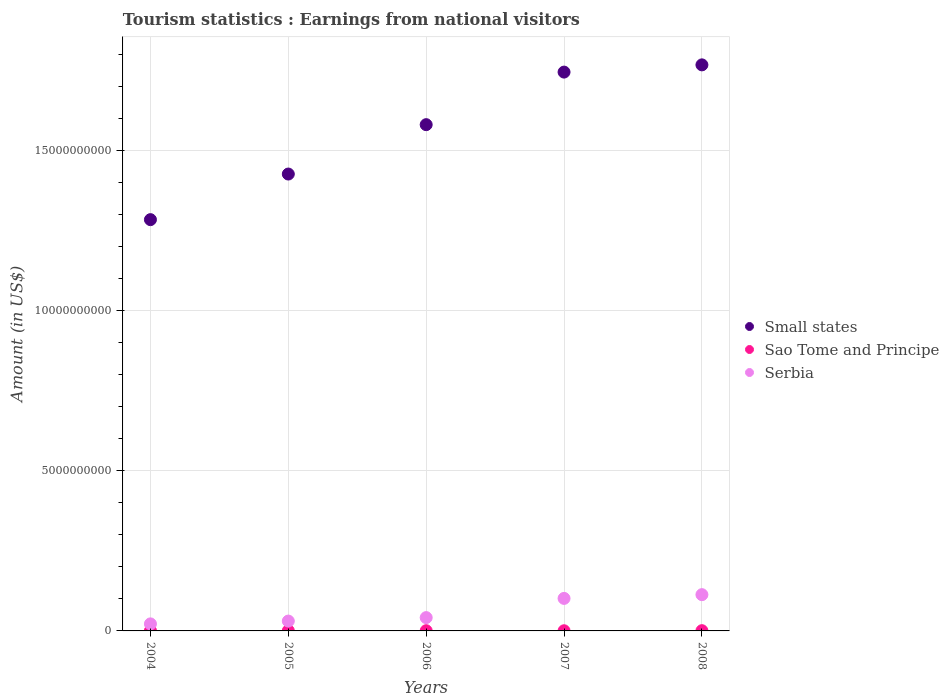What is the earnings from national visitors in Serbia in 2005?
Offer a very short reply. 3.08e+08. Across all years, what is the maximum earnings from national visitors in Serbia?
Your answer should be compact. 1.13e+09. Across all years, what is the minimum earnings from national visitors in Small states?
Provide a short and direct response. 1.29e+1. In which year was the earnings from national visitors in Sao Tome and Principe minimum?
Provide a short and direct response. 2007. What is the total earnings from national visitors in Sao Tome and Principe in the graph?
Your answer should be very brief. 3.44e+07. What is the difference between the earnings from national visitors in Small states in 2005 and that in 2006?
Give a very brief answer. -1.54e+09. What is the difference between the earnings from national visitors in Serbia in 2006 and the earnings from national visitors in Sao Tome and Principe in 2008?
Keep it short and to the point. 4.08e+08. What is the average earnings from national visitors in Small states per year?
Give a very brief answer. 1.56e+1. In the year 2006, what is the difference between the earnings from national visitors in Sao Tome and Principe and earnings from national visitors in Small states?
Offer a terse response. -1.58e+1. In how many years, is the earnings from national visitors in Serbia greater than 1000000000 US$?
Your answer should be compact. 2. What is the ratio of the earnings from national visitors in Small states in 2007 to that in 2008?
Give a very brief answer. 0.99. What is the difference between the highest and the second highest earnings from national visitors in Serbia?
Your answer should be very brief. 1.17e+08. What is the difference between the highest and the lowest earnings from national visitors in Small states?
Make the answer very short. 4.84e+09. Is the earnings from national visitors in Small states strictly greater than the earnings from national visitors in Sao Tome and Principe over the years?
Offer a terse response. Yes. Is the earnings from national visitors in Small states strictly less than the earnings from national visitors in Sao Tome and Principe over the years?
Give a very brief answer. No. What is the difference between two consecutive major ticks on the Y-axis?
Give a very brief answer. 5.00e+09. Are the values on the major ticks of Y-axis written in scientific E-notation?
Make the answer very short. No. Where does the legend appear in the graph?
Keep it short and to the point. Center right. How are the legend labels stacked?
Ensure brevity in your answer.  Vertical. What is the title of the graph?
Your response must be concise. Tourism statistics : Earnings from national visitors. What is the label or title of the X-axis?
Give a very brief answer. Years. What is the label or title of the Y-axis?
Ensure brevity in your answer.  Amount (in US$). What is the Amount (in US$) of Small states in 2004?
Your response must be concise. 1.29e+1. What is the Amount (in US$) of Sao Tome and Principe in 2004?
Your answer should be very brief. 7.70e+06. What is the Amount (in US$) in Serbia in 2004?
Provide a short and direct response. 2.20e+08. What is the Amount (in US$) of Small states in 2005?
Make the answer very short. 1.43e+1. What is the Amount (in US$) in Sao Tome and Principe in 2005?
Provide a succinct answer. 7.30e+06. What is the Amount (in US$) in Serbia in 2005?
Ensure brevity in your answer.  3.08e+08. What is the Amount (in US$) in Small states in 2006?
Your answer should be compact. 1.58e+1. What is the Amount (in US$) of Sao Tome and Principe in 2006?
Provide a short and direct response. 6.70e+06. What is the Amount (in US$) of Serbia in 2006?
Offer a terse response. 4.16e+08. What is the Amount (in US$) in Small states in 2007?
Your response must be concise. 1.75e+1. What is the Amount (in US$) in Serbia in 2007?
Keep it short and to the point. 1.02e+09. What is the Amount (in US$) of Small states in 2008?
Make the answer very short. 1.77e+1. What is the Amount (in US$) of Sao Tome and Principe in 2008?
Your answer should be compact. 7.70e+06. What is the Amount (in US$) of Serbia in 2008?
Your answer should be very brief. 1.13e+09. Across all years, what is the maximum Amount (in US$) of Small states?
Ensure brevity in your answer.  1.77e+1. Across all years, what is the maximum Amount (in US$) in Sao Tome and Principe?
Provide a succinct answer. 7.70e+06. Across all years, what is the maximum Amount (in US$) of Serbia?
Make the answer very short. 1.13e+09. Across all years, what is the minimum Amount (in US$) in Small states?
Your answer should be compact. 1.29e+1. Across all years, what is the minimum Amount (in US$) in Serbia?
Provide a short and direct response. 2.20e+08. What is the total Amount (in US$) in Small states in the graph?
Ensure brevity in your answer.  7.81e+1. What is the total Amount (in US$) of Sao Tome and Principe in the graph?
Offer a terse response. 3.44e+07. What is the total Amount (in US$) of Serbia in the graph?
Your answer should be very brief. 3.09e+09. What is the difference between the Amount (in US$) of Small states in 2004 and that in 2005?
Your response must be concise. -1.43e+09. What is the difference between the Amount (in US$) of Sao Tome and Principe in 2004 and that in 2005?
Ensure brevity in your answer.  4.00e+05. What is the difference between the Amount (in US$) in Serbia in 2004 and that in 2005?
Offer a terse response. -8.80e+07. What is the difference between the Amount (in US$) in Small states in 2004 and that in 2006?
Make the answer very short. -2.97e+09. What is the difference between the Amount (in US$) in Serbia in 2004 and that in 2006?
Give a very brief answer. -1.96e+08. What is the difference between the Amount (in US$) in Small states in 2004 and that in 2007?
Provide a short and direct response. -4.61e+09. What is the difference between the Amount (in US$) in Sao Tome and Principe in 2004 and that in 2007?
Your answer should be very brief. 2.70e+06. What is the difference between the Amount (in US$) of Serbia in 2004 and that in 2007?
Make the answer very short. -7.96e+08. What is the difference between the Amount (in US$) in Small states in 2004 and that in 2008?
Offer a very short reply. -4.84e+09. What is the difference between the Amount (in US$) of Sao Tome and Principe in 2004 and that in 2008?
Give a very brief answer. 0. What is the difference between the Amount (in US$) in Serbia in 2004 and that in 2008?
Ensure brevity in your answer.  -9.13e+08. What is the difference between the Amount (in US$) of Small states in 2005 and that in 2006?
Your answer should be compact. -1.54e+09. What is the difference between the Amount (in US$) in Serbia in 2005 and that in 2006?
Ensure brevity in your answer.  -1.08e+08. What is the difference between the Amount (in US$) in Small states in 2005 and that in 2007?
Give a very brief answer. -3.19e+09. What is the difference between the Amount (in US$) in Sao Tome and Principe in 2005 and that in 2007?
Offer a terse response. 2.30e+06. What is the difference between the Amount (in US$) in Serbia in 2005 and that in 2007?
Give a very brief answer. -7.08e+08. What is the difference between the Amount (in US$) of Small states in 2005 and that in 2008?
Your answer should be compact. -3.41e+09. What is the difference between the Amount (in US$) in Sao Tome and Principe in 2005 and that in 2008?
Offer a very short reply. -4.00e+05. What is the difference between the Amount (in US$) of Serbia in 2005 and that in 2008?
Keep it short and to the point. -8.25e+08. What is the difference between the Amount (in US$) of Small states in 2006 and that in 2007?
Your answer should be very brief. -1.64e+09. What is the difference between the Amount (in US$) in Sao Tome and Principe in 2006 and that in 2007?
Your response must be concise. 1.70e+06. What is the difference between the Amount (in US$) in Serbia in 2006 and that in 2007?
Your response must be concise. -6.00e+08. What is the difference between the Amount (in US$) of Small states in 2006 and that in 2008?
Your answer should be compact. -1.87e+09. What is the difference between the Amount (in US$) of Serbia in 2006 and that in 2008?
Offer a terse response. -7.17e+08. What is the difference between the Amount (in US$) in Small states in 2007 and that in 2008?
Your answer should be compact. -2.26e+08. What is the difference between the Amount (in US$) in Sao Tome and Principe in 2007 and that in 2008?
Your response must be concise. -2.70e+06. What is the difference between the Amount (in US$) in Serbia in 2007 and that in 2008?
Offer a terse response. -1.17e+08. What is the difference between the Amount (in US$) of Small states in 2004 and the Amount (in US$) of Sao Tome and Principe in 2005?
Provide a short and direct response. 1.28e+1. What is the difference between the Amount (in US$) in Small states in 2004 and the Amount (in US$) in Serbia in 2005?
Your answer should be very brief. 1.25e+1. What is the difference between the Amount (in US$) of Sao Tome and Principe in 2004 and the Amount (in US$) of Serbia in 2005?
Provide a succinct answer. -3.00e+08. What is the difference between the Amount (in US$) in Small states in 2004 and the Amount (in US$) in Sao Tome and Principe in 2006?
Provide a succinct answer. 1.28e+1. What is the difference between the Amount (in US$) in Small states in 2004 and the Amount (in US$) in Serbia in 2006?
Provide a succinct answer. 1.24e+1. What is the difference between the Amount (in US$) in Sao Tome and Principe in 2004 and the Amount (in US$) in Serbia in 2006?
Give a very brief answer. -4.08e+08. What is the difference between the Amount (in US$) of Small states in 2004 and the Amount (in US$) of Sao Tome and Principe in 2007?
Offer a very short reply. 1.28e+1. What is the difference between the Amount (in US$) in Small states in 2004 and the Amount (in US$) in Serbia in 2007?
Offer a very short reply. 1.18e+1. What is the difference between the Amount (in US$) in Sao Tome and Principe in 2004 and the Amount (in US$) in Serbia in 2007?
Offer a terse response. -1.01e+09. What is the difference between the Amount (in US$) in Small states in 2004 and the Amount (in US$) in Sao Tome and Principe in 2008?
Offer a terse response. 1.28e+1. What is the difference between the Amount (in US$) in Small states in 2004 and the Amount (in US$) in Serbia in 2008?
Give a very brief answer. 1.17e+1. What is the difference between the Amount (in US$) in Sao Tome and Principe in 2004 and the Amount (in US$) in Serbia in 2008?
Your answer should be very brief. -1.13e+09. What is the difference between the Amount (in US$) of Small states in 2005 and the Amount (in US$) of Sao Tome and Principe in 2006?
Provide a short and direct response. 1.43e+1. What is the difference between the Amount (in US$) in Small states in 2005 and the Amount (in US$) in Serbia in 2006?
Your answer should be compact. 1.39e+1. What is the difference between the Amount (in US$) in Sao Tome and Principe in 2005 and the Amount (in US$) in Serbia in 2006?
Ensure brevity in your answer.  -4.09e+08. What is the difference between the Amount (in US$) of Small states in 2005 and the Amount (in US$) of Sao Tome and Principe in 2007?
Offer a terse response. 1.43e+1. What is the difference between the Amount (in US$) of Small states in 2005 and the Amount (in US$) of Serbia in 2007?
Your response must be concise. 1.33e+1. What is the difference between the Amount (in US$) of Sao Tome and Principe in 2005 and the Amount (in US$) of Serbia in 2007?
Offer a very short reply. -1.01e+09. What is the difference between the Amount (in US$) in Small states in 2005 and the Amount (in US$) in Sao Tome and Principe in 2008?
Provide a succinct answer. 1.43e+1. What is the difference between the Amount (in US$) of Small states in 2005 and the Amount (in US$) of Serbia in 2008?
Give a very brief answer. 1.31e+1. What is the difference between the Amount (in US$) of Sao Tome and Principe in 2005 and the Amount (in US$) of Serbia in 2008?
Offer a very short reply. -1.13e+09. What is the difference between the Amount (in US$) of Small states in 2006 and the Amount (in US$) of Sao Tome and Principe in 2007?
Keep it short and to the point. 1.58e+1. What is the difference between the Amount (in US$) in Small states in 2006 and the Amount (in US$) in Serbia in 2007?
Provide a short and direct response. 1.48e+1. What is the difference between the Amount (in US$) in Sao Tome and Principe in 2006 and the Amount (in US$) in Serbia in 2007?
Keep it short and to the point. -1.01e+09. What is the difference between the Amount (in US$) in Small states in 2006 and the Amount (in US$) in Sao Tome and Principe in 2008?
Make the answer very short. 1.58e+1. What is the difference between the Amount (in US$) in Small states in 2006 and the Amount (in US$) in Serbia in 2008?
Your answer should be compact. 1.47e+1. What is the difference between the Amount (in US$) of Sao Tome and Principe in 2006 and the Amount (in US$) of Serbia in 2008?
Provide a succinct answer. -1.13e+09. What is the difference between the Amount (in US$) in Small states in 2007 and the Amount (in US$) in Sao Tome and Principe in 2008?
Provide a short and direct response. 1.75e+1. What is the difference between the Amount (in US$) of Small states in 2007 and the Amount (in US$) of Serbia in 2008?
Offer a very short reply. 1.63e+1. What is the difference between the Amount (in US$) in Sao Tome and Principe in 2007 and the Amount (in US$) in Serbia in 2008?
Keep it short and to the point. -1.13e+09. What is the average Amount (in US$) in Small states per year?
Your answer should be very brief. 1.56e+1. What is the average Amount (in US$) in Sao Tome and Principe per year?
Your response must be concise. 6.88e+06. What is the average Amount (in US$) of Serbia per year?
Give a very brief answer. 6.19e+08. In the year 2004, what is the difference between the Amount (in US$) in Small states and Amount (in US$) in Sao Tome and Principe?
Give a very brief answer. 1.28e+1. In the year 2004, what is the difference between the Amount (in US$) of Small states and Amount (in US$) of Serbia?
Keep it short and to the point. 1.26e+1. In the year 2004, what is the difference between the Amount (in US$) of Sao Tome and Principe and Amount (in US$) of Serbia?
Keep it short and to the point. -2.12e+08. In the year 2005, what is the difference between the Amount (in US$) in Small states and Amount (in US$) in Sao Tome and Principe?
Provide a succinct answer. 1.43e+1. In the year 2005, what is the difference between the Amount (in US$) of Small states and Amount (in US$) of Serbia?
Keep it short and to the point. 1.40e+1. In the year 2005, what is the difference between the Amount (in US$) in Sao Tome and Principe and Amount (in US$) in Serbia?
Your answer should be very brief. -3.01e+08. In the year 2006, what is the difference between the Amount (in US$) of Small states and Amount (in US$) of Sao Tome and Principe?
Provide a short and direct response. 1.58e+1. In the year 2006, what is the difference between the Amount (in US$) in Small states and Amount (in US$) in Serbia?
Make the answer very short. 1.54e+1. In the year 2006, what is the difference between the Amount (in US$) of Sao Tome and Principe and Amount (in US$) of Serbia?
Ensure brevity in your answer.  -4.09e+08. In the year 2007, what is the difference between the Amount (in US$) of Small states and Amount (in US$) of Sao Tome and Principe?
Your answer should be compact. 1.75e+1. In the year 2007, what is the difference between the Amount (in US$) in Small states and Amount (in US$) in Serbia?
Your answer should be very brief. 1.64e+1. In the year 2007, what is the difference between the Amount (in US$) in Sao Tome and Principe and Amount (in US$) in Serbia?
Provide a short and direct response. -1.01e+09. In the year 2008, what is the difference between the Amount (in US$) of Small states and Amount (in US$) of Sao Tome and Principe?
Your answer should be compact. 1.77e+1. In the year 2008, what is the difference between the Amount (in US$) in Small states and Amount (in US$) in Serbia?
Provide a short and direct response. 1.66e+1. In the year 2008, what is the difference between the Amount (in US$) in Sao Tome and Principe and Amount (in US$) in Serbia?
Provide a short and direct response. -1.13e+09. What is the ratio of the Amount (in US$) of Small states in 2004 to that in 2005?
Make the answer very short. 0.9. What is the ratio of the Amount (in US$) of Sao Tome and Principe in 2004 to that in 2005?
Your answer should be very brief. 1.05. What is the ratio of the Amount (in US$) in Serbia in 2004 to that in 2005?
Your answer should be very brief. 0.71. What is the ratio of the Amount (in US$) of Small states in 2004 to that in 2006?
Keep it short and to the point. 0.81. What is the ratio of the Amount (in US$) in Sao Tome and Principe in 2004 to that in 2006?
Your response must be concise. 1.15. What is the ratio of the Amount (in US$) in Serbia in 2004 to that in 2006?
Give a very brief answer. 0.53. What is the ratio of the Amount (in US$) in Small states in 2004 to that in 2007?
Your answer should be very brief. 0.74. What is the ratio of the Amount (in US$) in Sao Tome and Principe in 2004 to that in 2007?
Give a very brief answer. 1.54. What is the ratio of the Amount (in US$) of Serbia in 2004 to that in 2007?
Give a very brief answer. 0.22. What is the ratio of the Amount (in US$) of Small states in 2004 to that in 2008?
Provide a succinct answer. 0.73. What is the ratio of the Amount (in US$) of Sao Tome and Principe in 2004 to that in 2008?
Provide a succinct answer. 1. What is the ratio of the Amount (in US$) in Serbia in 2004 to that in 2008?
Your answer should be very brief. 0.19. What is the ratio of the Amount (in US$) of Small states in 2005 to that in 2006?
Provide a short and direct response. 0.9. What is the ratio of the Amount (in US$) in Sao Tome and Principe in 2005 to that in 2006?
Offer a very short reply. 1.09. What is the ratio of the Amount (in US$) of Serbia in 2005 to that in 2006?
Ensure brevity in your answer.  0.74. What is the ratio of the Amount (in US$) of Small states in 2005 to that in 2007?
Make the answer very short. 0.82. What is the ratio of the Amount (in US$) in Sao Tome and Principe in 2005 to that in 2007?
Offer a terse response. 1.46. What is the ratio of the Amount (in US$) in Serbia in 2005 to that in 2007?
Keep it short and to the point. 0.3. What is the ratio of the Amount (in US$) of Small states in 2005 to that in 2008?
Your response must be concise. 0.81. What is the ratio of the Amount (in US$) of Sao Tome and Principe in 2005 to that in 2008?
Offer a very short reply. 0.95. What is the ratio of the Amount (in US$) of Serbia in 2005 to that in 2008?
Give a very brief answer. 0.27. What is the ratio of the Amount (in US$) of Small states in 2006 to that in 2007?
Your response must be concise. 0.91. What is the ratio of the Amount (in US$) in Sao Tome and Principe in 2006 to that in 2007?
Make the answer very short. 1.34. What is the ratio of the Amount (in US$) in Serbia in 2006 to that in 2007?
Offer a terse response. 0.41. What is the ratio of the Amount (in US$) in Small states in 2006 to that in 2008?
Make the answer very short. 0.89. What is the ratio of the Amount (in US$) in Sao Tome and Principe in 2006 to that in 2008?
Your answer should be compact. 0.87. What is the ratio of the Amount (in US$) in Serbia in 2006 to that in 2008?
Your answer should be compact. 0.37. What is the ratio of the Amount (in US$) in Small states in 2007 to that in 2008?
Keep it short and to the point. 0.99. What is the ratio of the Amount (in US$) of Sao Tome and Principe in 2007 to that in 2008?
Your answer should be compact. 0.65. What is the ratio of the Amount (in US$) in Serbia in 2007 to that in 2008?
Your answer should be compact. 0.9. What is the difference between the highest and the second highest Amount (in US$) in Small states?
Your answer should be very brief. 2.26e+08. What is the difference between the highest and the second highest Amount (in US$) of Sao Tome and Principe?
Offer a very short reply. 0. What is the difference between the highest and the second highest Amount (in US$) in Serbia?
Offer a terse response. 1.17e+08. What is the difference between the highest and the lowest Amount (in US$) in Small states?
Your answer should be compact. 4.84e+09. What is the difference between the highest and the lowest Amount (in US$) in Sao Tome and Principe?
Offer a terse response. 2.70e+06. What is the difference between the highest and the lowest Amount (in US$) in Serbia?
Provide a short and direct response. 9.13e+08. 